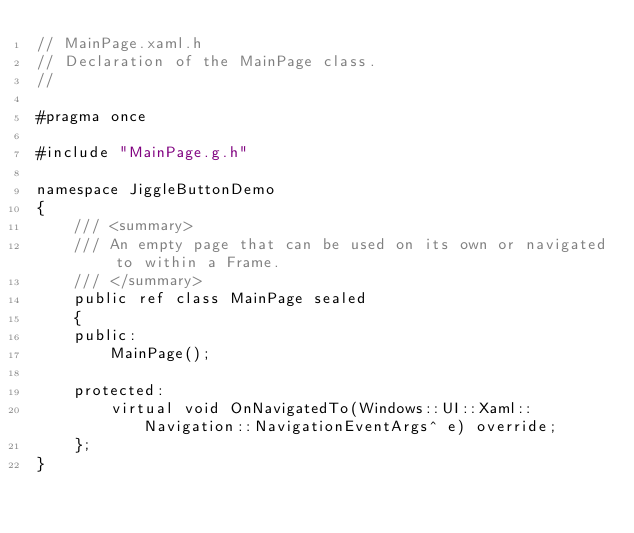<code> <loc_0><loc_0><loc_500><loc_500><_C_>// MainPage.xaml.h
// Declaration of the MainPage class.
//

#pragma once

#include "MainPage.g.h"

namespace JiggleButtonDemo
{
    /// <summary>
    /// An empty page that can be used on its own or navigated to within a Frame.
    /// </summary>
    public ref class MainPage sealed
    {
    public:
        MainPage();

    protected:
        virtual void OnNavigatedTo(Windows::UI::Xaml::Navigation::NavigationEventArgs^ e) override;
    };
}
</code> 